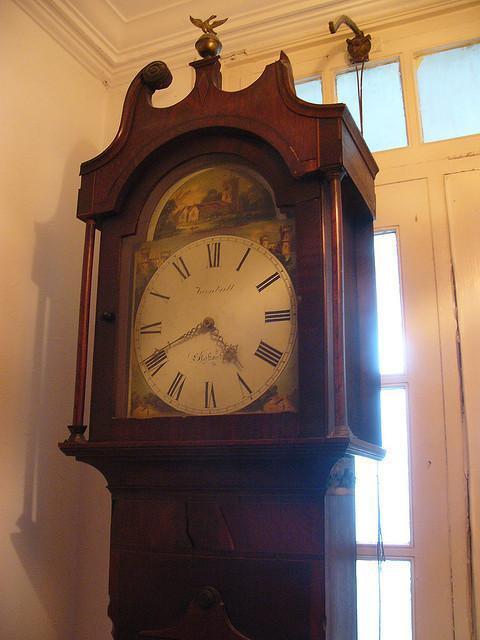How many teddy bears are wearing a hair bow?
Give a very brief answer. 0. 